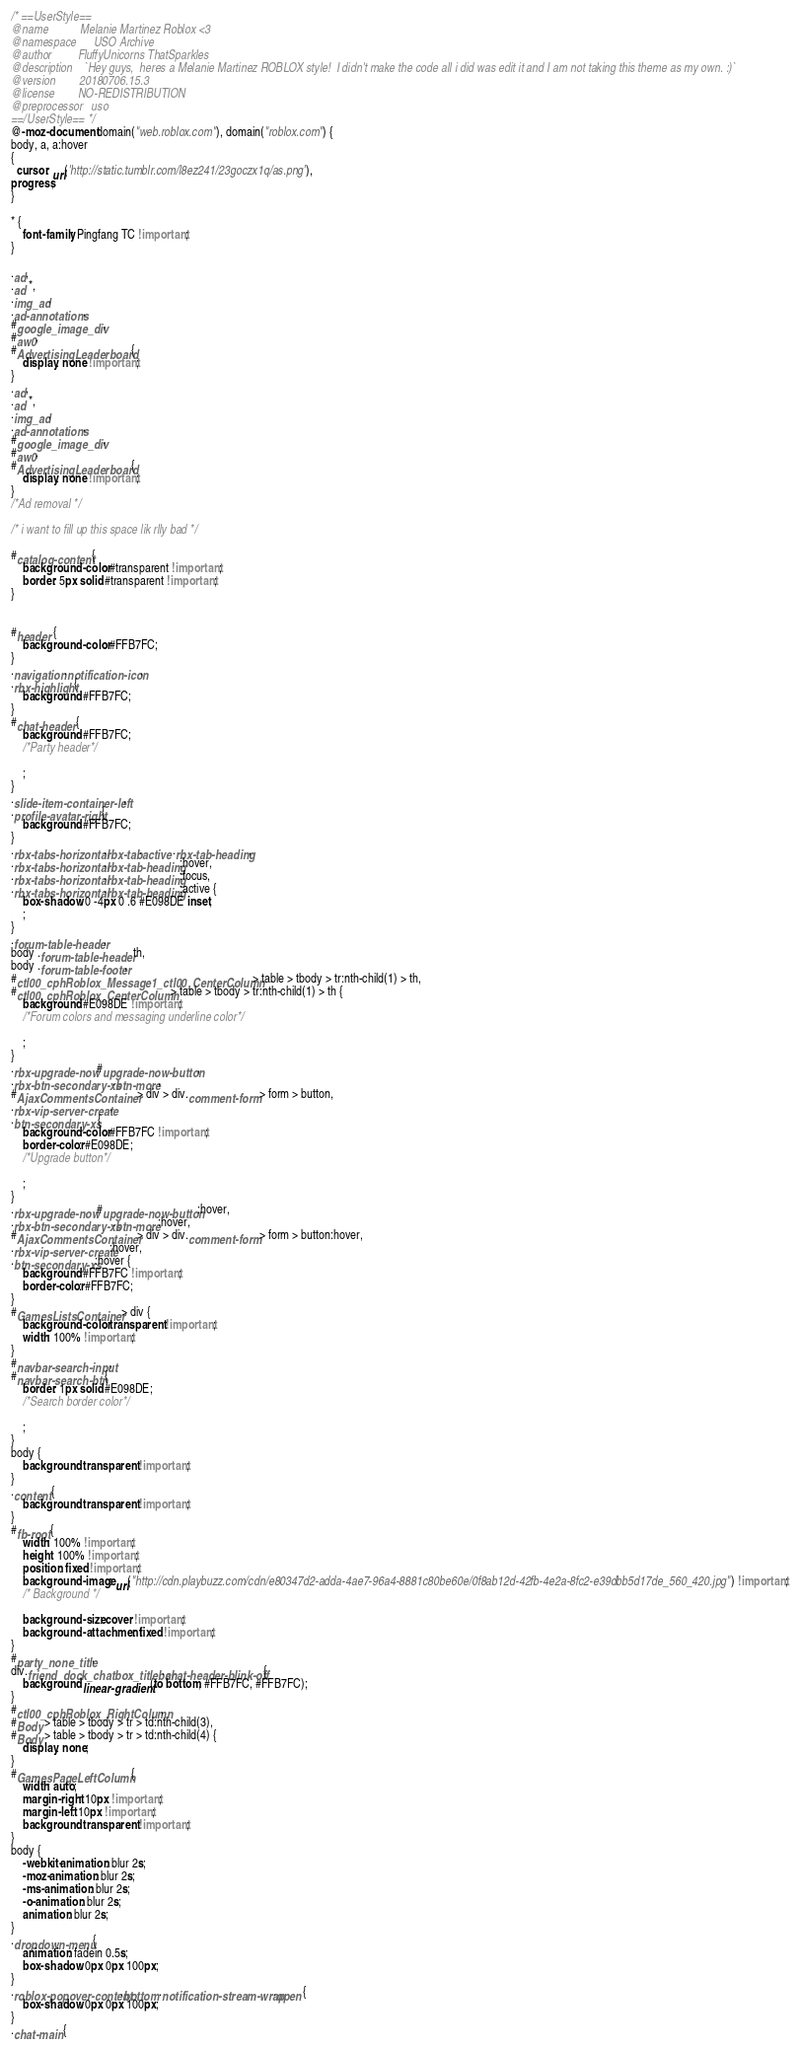<code> <loc_0><loc_0><loc_500><loc_500><_CSS_>/* ==UserStyle==
@name           Melanie Martinez Roblox <3
@namespace      USO Archive
@author         FluffyUnicorns ThatSparkles
@description    `Hey guys,  heres a Melanie Martinez ROBLOX style!  I didn't make the code all i did was edit it and I am not taking this theme as my own. :)`
@version        20180706.15.3
@license        NO-REDISTRIBUTION
@preprocessor   uso
==/UserStyle== */
@-moz-document domain("web.roblox.com"), domain("roblox.com") {
body, a, a:hover
{
  cursor: url('http://static.tumblr.com/l8ez241/23goczx1q/as.png'),
progress;
}

* {
    font-family: Pingfang TC !important;
}

.ad,
.ad *,
.img_ad,
.ad-annotations,
#google_image_div,
#aw0,
#AdvertisingLeaderboard {
    display: none !important;
}
.ad,
.ad *,
.img_ad,
.ad-annotations,
#google_image_div,
#aw0,
#AdvertisingLeaderboard {
    display: none !important;
}
/*Ad removal */

/* i want to fill up this space lik rlly bad */

#catalog-content {
    background-color: #transparent !important;
    border: 5px solid #transparent !important;
}


#header {
    background-color: #FFB7FC;
}
.navigation .notification-icon,
.rbx-highlight {
    background: #FFB7FC;
}
#chat-header {
    background: #FFB7FC;
    /*Party header*/
    
    ;
}
.slide-item-container-left,
.profile-avatar-right {
    background: #FFB7FC;
}
.rbx-tabs-horizontal .rbx-tab.active .rbx-tab-heading,
.rbx-tabs-horizontal .rbx-tab-heading:hover,
.rbx-tabs-horizontal .rbx-tab-heading:focus,
.rbx-tabs-horizontal .rbx-tab-heading:active {
    box-shadow: 0 -4px 0 .6 #E098DE inset;
    ;
}
.forum-table-header,
body .forum-table-header th,
body .forum-table-footer,
#ctl00_cphRoblox_Message1_ctl00_CenterColumn > table > tbody > tr:nth-child(1) > th,
#ctl00_cphRoblox_CenterColumn > table > tbody > tr:nth-child(1) > th {
    background: #E098DE !important;
    /*Forum colors and messaging underline color*/
    
    ;
}
.rbx-upgrade-now #upgrade-now-button,
.rbx-btn-secondary-xs.btn-more,
#AjaxCommentsContainer > div > div.comment-form > form > button,
.rbx-vip-server-create,
.btn-secondary-xs {
    background-color: #FFB7FC !important;
    border-color: #E098DE;
    /*Upgrade button*/
    
    ;
}
.rbx-upgrade-now #upgrade-now-button:hover,
.rbx-btn-secondary-xs.btn-more:hover,
#AjaxCommentsContainer > div > div.comment-form > form > button:hover,
.rbx-vip-server-create:hover,
.btn-secondary-xs:hover {
    background: #FFB7FC !important;
    border-color: #FFB7FC;
}
#GamesListsContainer > div {
    background-color: transparent !important;
    width: 100% !important;
}
#navbar-search-input,
#navbar-search-btn {
    border: 1px solid #E098DE;
    /*Search border color*/
    
    ;
}
body {
    background: transparent !important;
}
.content {
    background: transparent !important;
}
#fb-root {
    width: 100% !important;
    height: 100% !important;
    position: fixed !important;
    background-image: url("http://cdn.playbuzz.com/cdn/e80347d2-adda-4ae7-96a4-8881c80be60e/0f8ab12d-42fb-4e2a-8fc2-e39dbb5d17de_560_420.jpg") !important;
    /* Background */
    
    background-size: cover !important;
    background-attachment: fixed !important;
}
#party_none_title,
div.friend_dock_chatbox_titlebar.chat-header-blink-off {
    background: linear-gradient(to bottom, #FFB7FC, #FFB7FC);
}
#ctl00_cphRoblox_RightColumn,
#Body > table > tbody > tr > td:nth-child(3),
#Body > table > tbody > tr > td:nth-child(4) {
    display: none;
}
#GamesPageLeftColumn {
    width: auto;
    margin-right: 10px !important;
    margin-left: 10px !important;
    background: transparent !important;
}
body {
    -webkit-animation: blur 2s;
    -moz-animation: blur 2s;
    -ms-animation: blur 2s;
    -o-animation: blur 2s;
    animation: blur 2s;
}
.dropdown-menu {
    animation: fadein 0.5s;
    box-shadow: 0px 0px 100px;
}
.roblox-popover-content.bottom .notification-stream-wrap.open {
    box-shadow: 0px 0px 100px;
}
.chat-main {</code> 